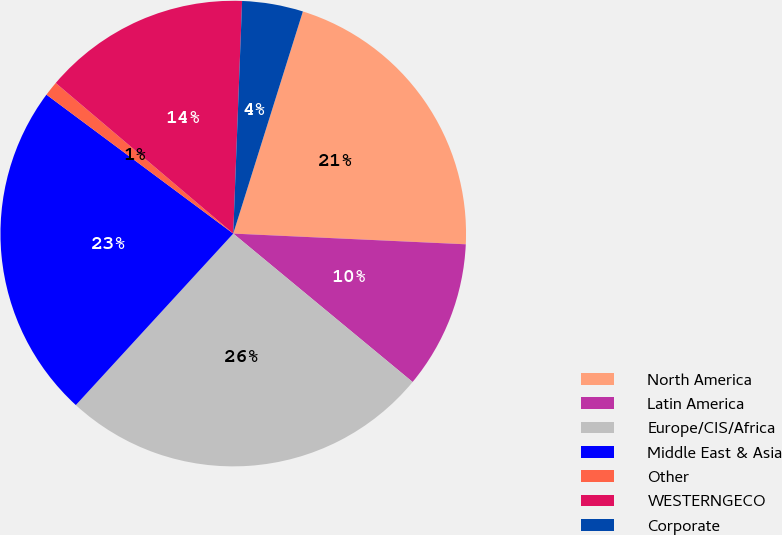<chart> <loc_0><loc_0><loc_500><loc_500><pie_chart><fcel>North America<fcel>Latin America<fcel>Europe/CIS/Africa<fcel>Middle East & Asia<fcel>Other<fcel>WESTERNGECO<fcel>Corporate<nl><fcel>20.9%<fcel>10.27%<fcel>25.82%<fcel>23.36%<fcel>1.02%<fcel>14.41%<fcel>4.23%<nl></chart> 